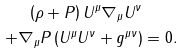Convert formula to latex. <formula><loc_0><loc_0><loc_500><loc_500>\left ( \rho + P \right ) U ^ { \mu } \nabla _ { \mu } U ^ { \nu } \quad \\ + \nabla _ { \mu } P \left ( U ^ { \mu } U ^ { \nu } + g ^ { \mu \nu } \right ) = 0 .</formula> 